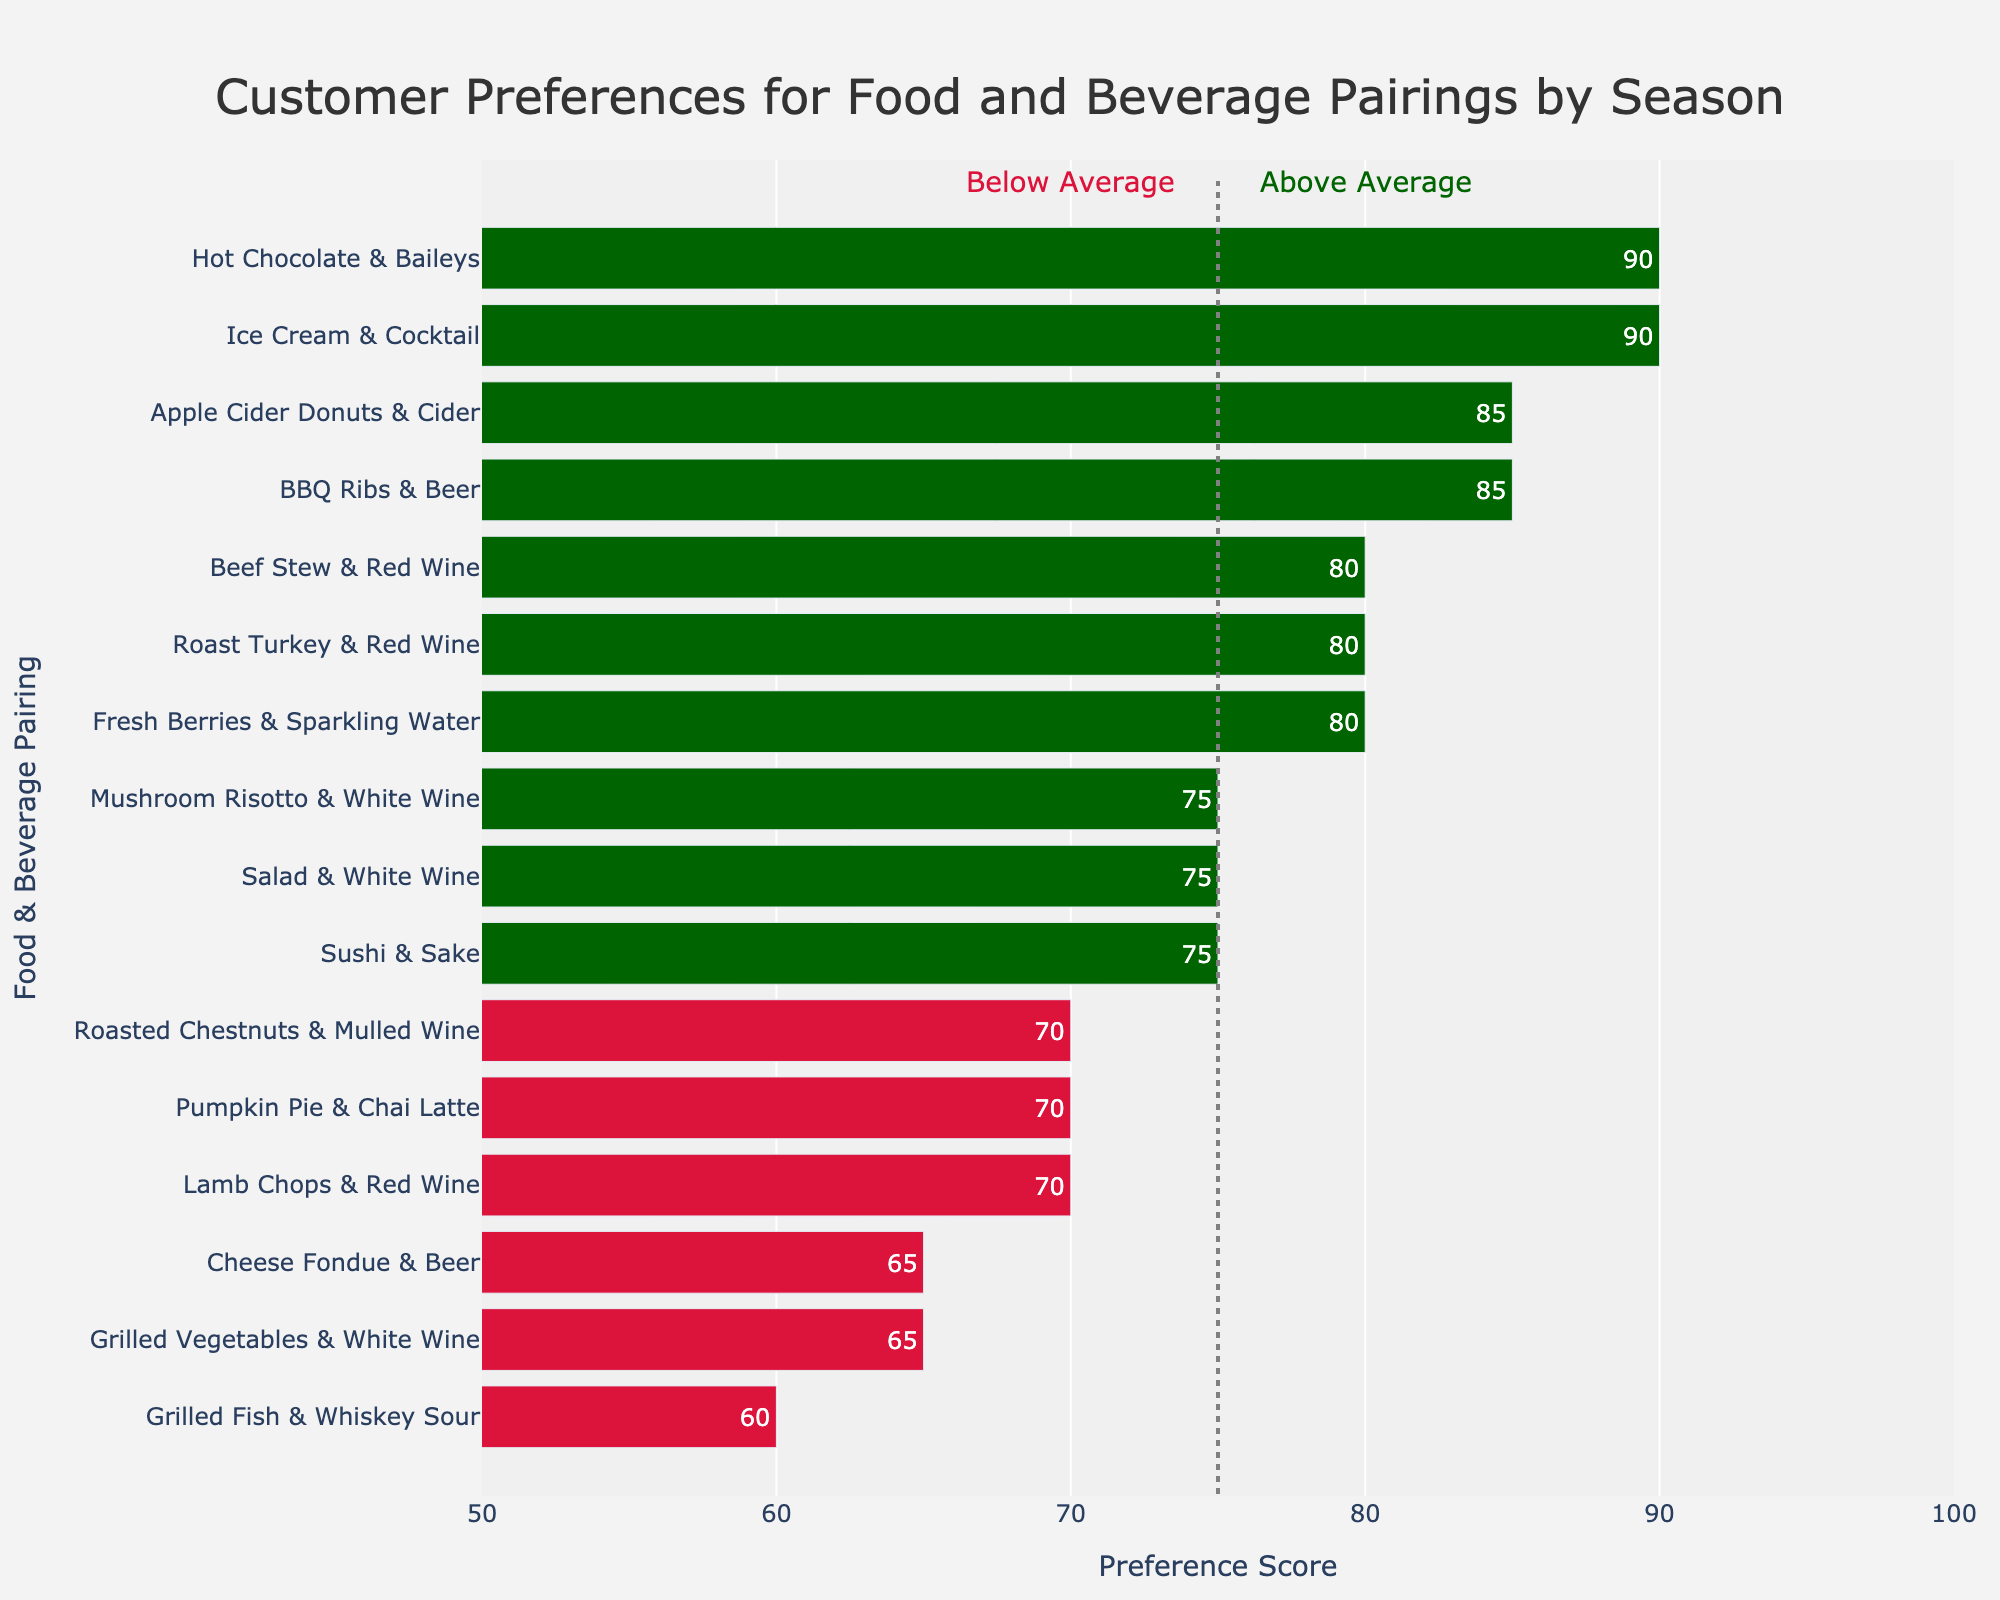What's the most preferred food & beverage pairing for each season? Identify from the figure the pairing with the highest preference score for each season. For Spring, Fresh Berries & Sparkling Water has the highest score. For Summer, Ice Cream & Cocktail has the highest score. For Autumn, Apple Cider Donuts & Cider has the highest score. For Winter, Hot Chocolate & Baileys has the highest score.
Answer: Fresh Berries & Sparkling Water (Spring), Ice Cream & Cocktail (Summer), Apple Cider Donuts & Cider (Autumn), Hot Chocolate & Baileys (Winter) Which food & beverage pairing has the lowest preference score overall? Locate the bar with the shortest length and lowest value. Grilled Fish & Whiskey Sour in Summer has the lowest preference score of 60.
Answer: Grilled Fish & Whiskey Sour (60) How many pairings have a preference score below the average threshold of 75? Count the number of bars colored in crimson, representing preference scores below 75. The figure shows there are 5 pairings below this threshold.
Answer: 5 What is the difference in preference score between the highest ranking pairings in Spring and Autumn? Identify the highest preference scoring pairings in Spring and Autumn, then calculate the difference. Fresh Berries & Sparkling Water in Spring has a score of 80. Apple Cider Donuts & Cider in Autumn has a score of 85. The difference is 85 - 80.
Answer: 5 Which season has the highest average preference score for its pairings? Calculate the average preference score for each season. Compare the averages to find the highest. The average scores are: Spring (72.5), Summer (77.5), Autumn (77.5), Winter (76.25). Summer and Autumn both have the highest average of 77.5.
Answer: Summer & Autumn Are there more pairings above or below the average threshold of 75? Count the number of bars above and below the 75 threshold. There are 9 bars above and 7 below the threshold, meaning more pairings are above the threshold.
Answer: Above Compare the preference scores between Lamb Chops & Red Wine in Spring and Beef Stew & Red Wine in Winter. Which one is higher and by how much? Locate the bars for Lamb Chops & Red Wine and Beef Stew & Red Wine. The scores are 70 and 80, respectively. Beef Stew & Red Wine is higher by 10 points.
Answer: Beef Stew & Red Wine, by 10 What's the median preference score for the food & beverage pairings? Arrange all preference scores in ascending order to identify the middle value. The sorted scores are 60, 65, 65, 70, 70, 75, 75, 75, 75, 80, 80, 80, 85, 85, 90, 90. With 16 scores, the median is the average of the 8th and 9th values: (75+75)/2.
Answer: 75 